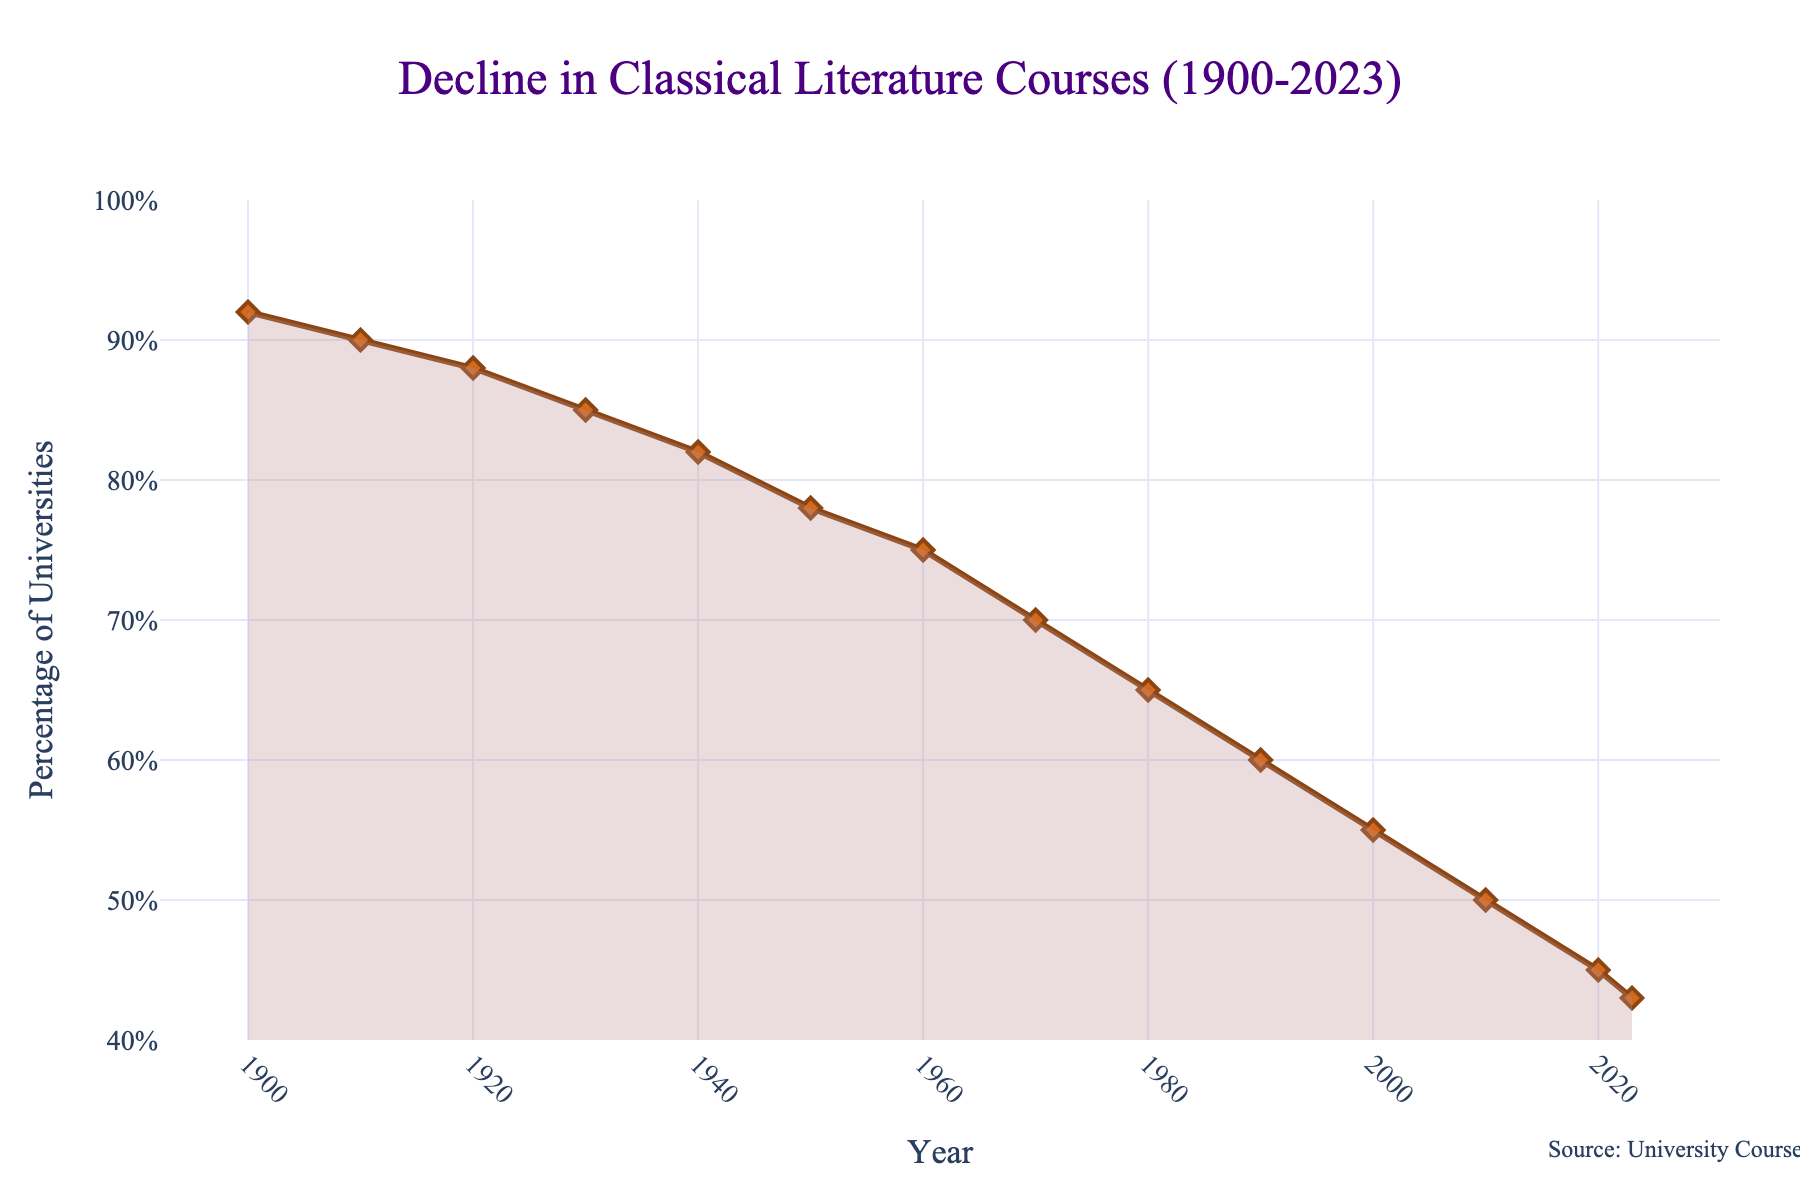What is the general trend of classical literature course offerings from 1900 to 2023? The general trend is determined by observing the percentage of universities offering classical literature courses over time. It shows a decline from 92% in 1900 to 43% in 2023. The trend is consistently downward.
Answer: Declining How much did the percentage of universities offering classical literature courses drop from 1900 to 2023? Subtract the percentage in 2023 from the percentage in 1900. (92% - 43% = 49%)
Answer: 49% Between which two consecutive decades did the percentage of universities offering classical literature courses decrease the most? By examining the difference between consecutive decades, we find the largest decrease: between 1950 (78%) and 1960 (75%). The largest drop is 8%.
Answer: 1950 to 1960 What is the percentage of universities offering classical literature courses in the year 2000? Read the value corresponding to the year 2000 on the plot. The percentage is 55%.
Answer: 55% How does the percentage in 2020 compare to that in 1910? Observe and compare the values for 1910 and 2020 from the chart. 1910 value is 90%, and 2020 value is 45%. 45% is 50% of 90%.
Answer: 50% What color is used to fill the shaded area under the line representing the decline in course offerings? Identify the fill color used in the shaded area under the line. The shaded area is filled with a light brown or tan color.
Answer: Light brown or tan What mathematical relationship best describes the decline from 1900 to 2023: linear, exponential, or other? By examining the shape of the line graph, the decline appears relatively smooth and linear rather than exponential or showing other characteristic curves.
Answer: Linear What is the average percentage of universities offering classical literature courses over the period from 1900 to 2023? Add the percentages for each year and divide by the number of years (14 years). Average = (92+90+88+85+82+78+75+70+65+60+55+50+45+43)/14 ≈ 70.14%
Answer: 70.14% From the data presented, was there any period of increase in the percentage of universities offering classical literature courses? Check each consecutive pair of years to see if there was an increase. There was no period of increase; it consistently declined.
Answer: No What is the visual trend in the line thickness and marker size and shape in the plot? Assess the properties of the visual elements in the graph. The line is thick, around 3 pixels wide. Markers are sizable, diamond-shaped.
Answer: Thick line, large diamond markers 